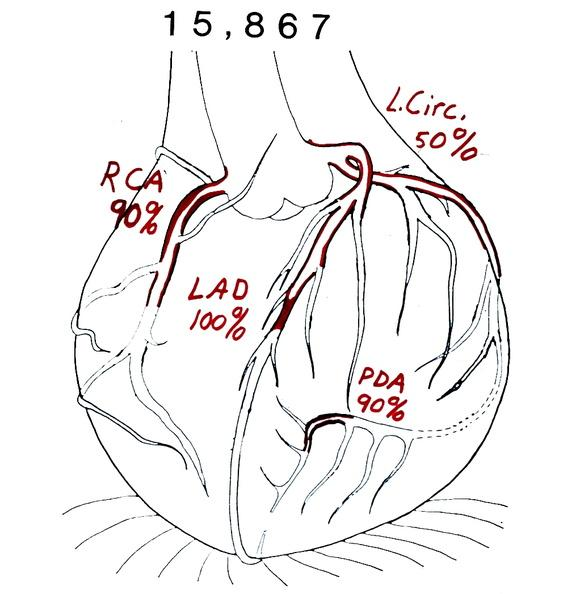what does this image show?
Answer the question using a single word or phrase. Coronary artery atherosclerosis diagram 